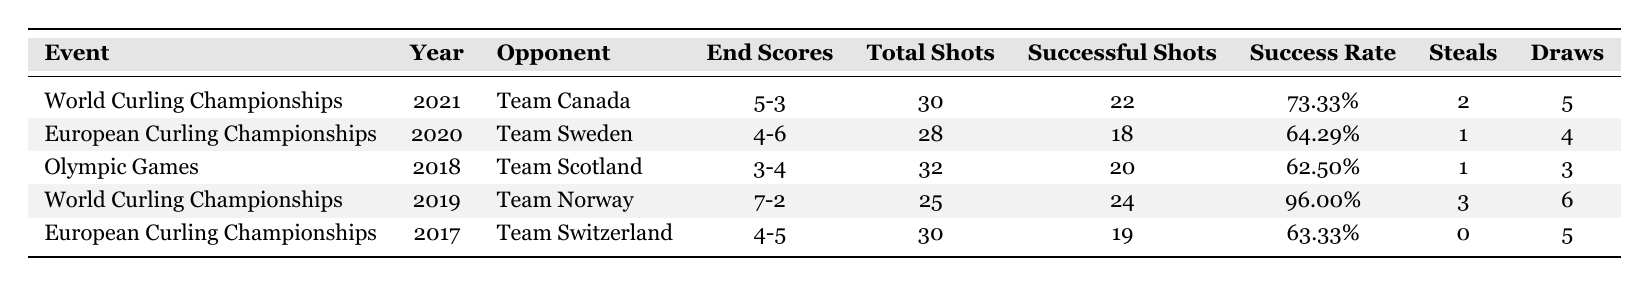What was the highest success rate achieved by Enrico Alberti in a match? The highest success rate is found in the match against Team Norway in 2019, where the success rate is 96.00%.
Answer: 96.00% How many total steals did Enrico Alberti record in the World Curling Championships? To find the totals for the World Curling Championships, I sum the steals from the matches in 2021 (2) and 2019 (3), which gives 2 + 3 = 5.
Answer: 5 Which opponent did Enrico Alberti face in the year with the lowest success rate? The lowest success rate is 62.50%, which occurred in the match against Team Scotland during the Olympic Games in 2018.
Answer: Team Scotland What is the average number of draws Enrico Alberti achieved in the European Curling Championships? To calculate the average, I take the draws from both matches: in 2020 it was 4 and in 2017 it was 5. So the average is (4 + 5)/2 = 4.5.
Answer: 4.5 Did Enrico Alberti manage to win against Team Canada in the World Curling Championships of 2021? The end score against Team Canada was 5-3, which indicates a win for Enrico Alberti since he scored more points.
Answer: Yes How many successful shots did Enrico Alberti take against Team Sweden during the European Curling Championships in 2020? The number of successful shots against Team Sweden is listed directly in the data, which is 18.
Answer: 18 Which year did Enrico Alberti have the highest number of total shots? The highest total shots are from the Olympic Games in 2018, where he made 32 total shots.
Answer: 2018 What is the difference in successful shots between Enrico Alberti's matches against Team Norway and Team Canada? The successful shots against Team Norway are 24 and against Team Canada are 22. The difference is 24 - 22 = 2.
Answer: 2 Was there a match where Enrico Alberti did not have any steals? In the match against Team Switzerland in 2017, he recorded 0 steals.
Answer: Yes Which event had the closest final score against Enrico Alberti? The closest match was against Team Scotland in the Olympic Games, with a score of 3-4, a difference of just one point.
Answer: Olympic Games 